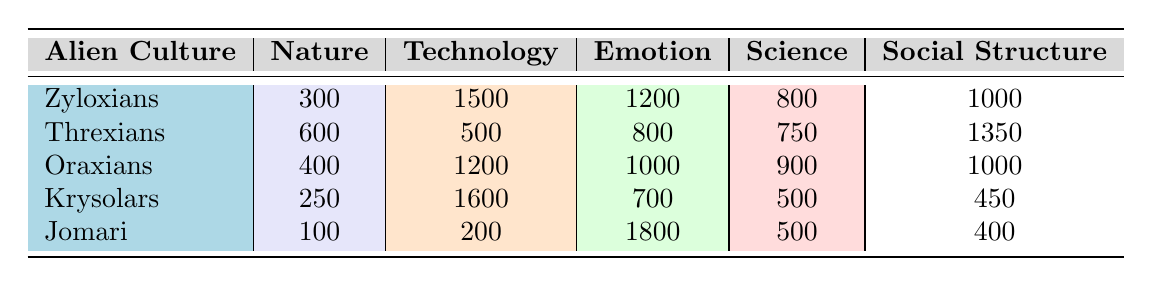What is the vocabulary size of Zyloxians? The vocabulary size is directly listed under the Zyloxians row in the table. The value given is 5000.
Answer: 5000 Which alien culture has the highest vocabulary size? By comparing the vocabulary sizes listed for each culture, Zyloxians have the highest vocabulary size of 5000.
Answer: Zyloxians What is the total number of 'Emotion' vocabulary entries across all cultures? The total can be found by summing the 'Emotion' values from each culture: (1200 + 800 + 1000 + 700 + 1800) = 4500.
Answer: 4500 Are there any cultures with more than 1000 vocabulary entries for 'Technology'? We check each culture's 'Technology' value: Zyloxians (1500), Oraxians (1200), and Krysolars (1600) have more than 1000.
Answer: Yes Which culture has the lowest vocabulary size and how many entries does it have? We look through the vocabulary sizes listed. Jomari has the lowest vocabulary size of 3000.
Answer: Jomari, 3000 If we combine the 'Nature' vocabulary entries of Zyloxians, Threxians, and Oraxians, what would be their total? Adding the 'Nature' values for these cultures: (300 + 600 + 400) = 1300.
Answer: 1300 What fraction of the vocabulary size of Krysolars is dedicated to 'Social Structure'? To find the fraction, we calculate: the 'Social Structure' entry is 450 and the total vocabulary size is 3500, so the fraction is 450/3500, which simplifies to 0.12857 or about 12.86%.
Answer: Approximately 0.12857 Is the number of vocabulary entries for 'Science' greater in Threxians than in Jomari? The 'Science' values for Threxians (750) and Jomari (500) show that Threxians have more entries.
Answer: Yes What is the average number of vocabulary entries for 'Nature' across all listed cultures? The 'Nature' values summed up is (300 + 600 + 400 + 250 + 100) = 1650. There are 5 cultures, so the average is 1650/5 = 330.
Answer: 330 